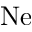<formula> <loc_0><loc_0><loc_500><loc_500>N e</formula> 